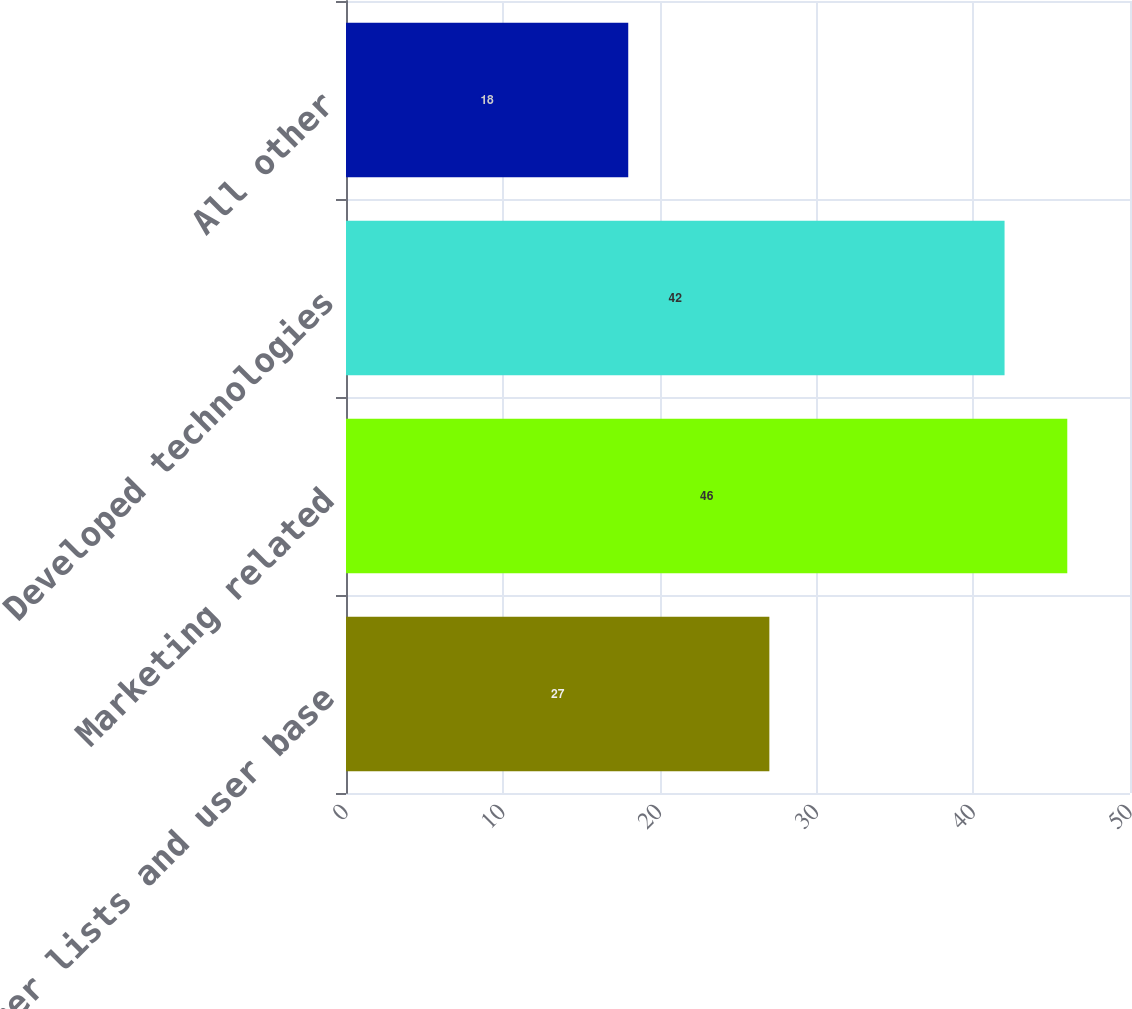<chart> <loc_0><loc_0><loc_500><loc_500><bar_chart><fcel>Customer lists and user base<fcel>Marketing related<fcel>Developed technologies<fcel>All other<nl><fcel>27<fcel>46<fcel>42<fcel>18<nl></chart> 